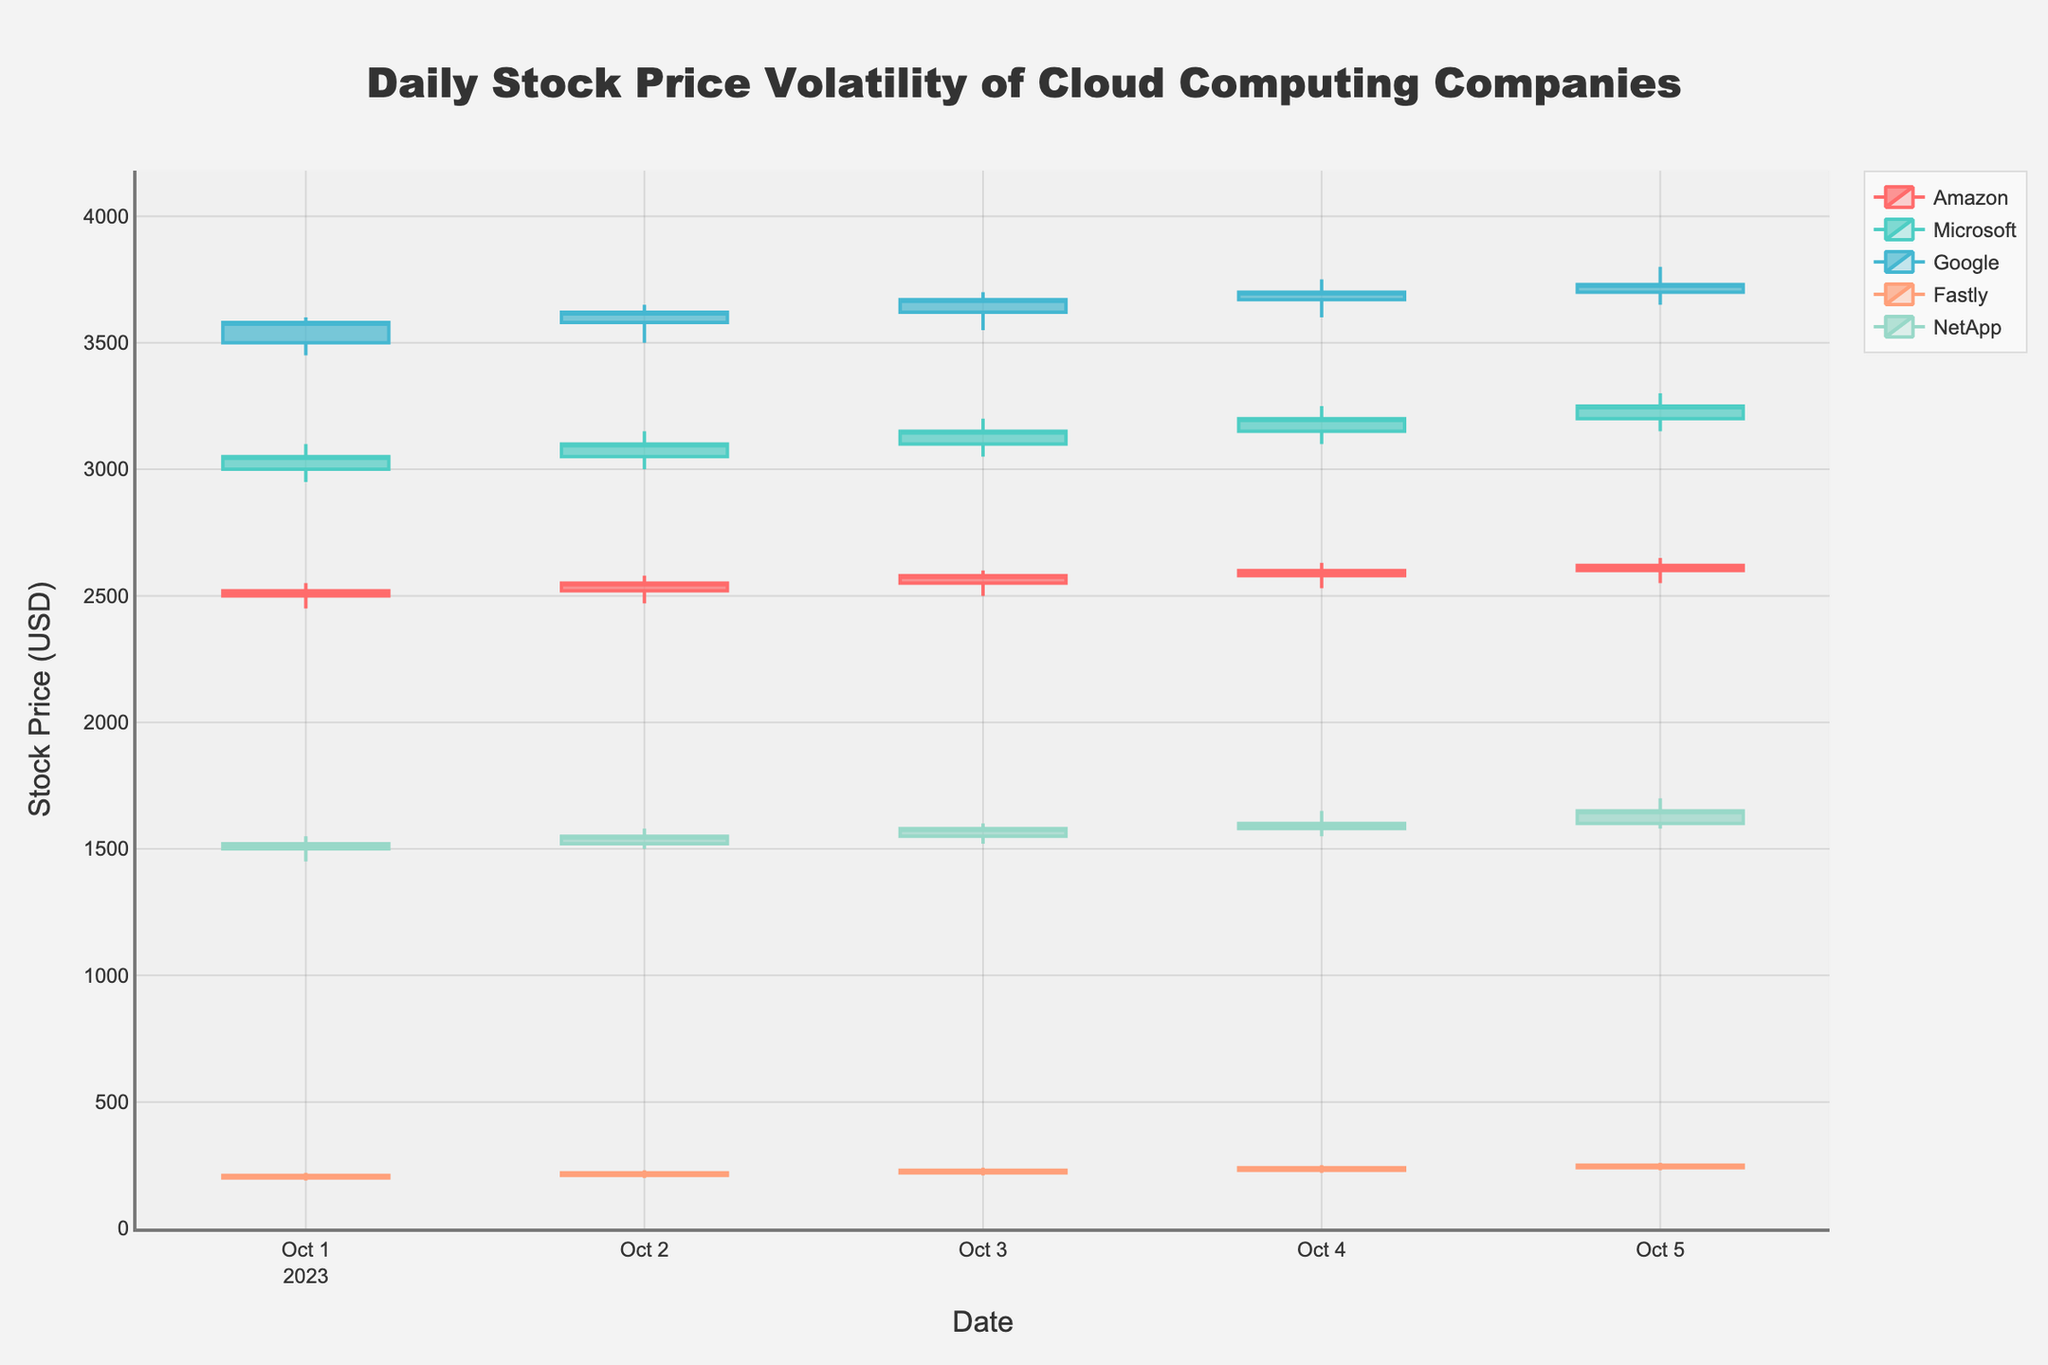Which company had the highest stock price on October 5th? Look for the highest 'High' value on October 5th in the candlestick plot and observe the corresponding company name. Google had the highest value at $3800 on October 5th.
Answer: Google What was the closing price of Microsoft on October 3rd? Look for the candlestick representing Microsoft for October 3rd and read the closing price. The closing price of Microsoft on October 3rd was $3150.
Answer: $3150 Between Amazon and NetApp, which company had a larger range between its highest and lowest stock prices on October 2nd? Calculate the range as `High - Low` for both Amazon and NetApp on October 2nd. Amazon's range: $2580 - $2470 = $110. NetApp's range: $1580 - $1500 = $80. Amazon has the larger range.
Answer: Amazon Which day did Fastly have the highest trading volume? Identify the volume values for Fastly over the days and compare them to find the maximum. Fastly's highest trading volume was 770000 on October 5th.
Answer: October 5th What is the overall trend of Google's stock prices from October 1st to October 5th? Observe the closing prices of Google's candlesticks over multiple days to determine if the stock is generally increasing, decreasing, or fluctuating. Google's closing prices show an increasing trend from October 1st to October 5th, moving from $3580 to $3730.
Answer: Increasing Between October 3rd and October 4th, did Amazon's stock price increase or decrease? Compare the closing prices of Amazon on October 3rd and October 4th in the candlestick plot. Amazon's closing price increased from $2580 on October 3rd to $2600 on October 4th.
Answer: Increased How does the volume of shares traded by Fastly on October 4th compare to that of NetApp on the same day? Refer to the volume values of both companies on October 4th and compare them. Fastly traded 750000 shares, compared to NetApp's 500000 shares on October 4th. Fastly had a higher trading volume.
Answer: Fastly Over the five days, which company shows the most consistent closing prices? Analyze the closing prices for each company over the five-day period and determine which one has the least fluctuation. Compare closing prices for Amazon, Microsoft, Google, Fastly, and NetApp over the given days. Microsoft has relatively stable closing prices ranging between $3050 and $3250.
Answer: Microsoft By how much did NetApp's closing price change from October 1st to October 5th? Subtract the closing price of NetApp on October 1st from the closing price on October 5th. Closing price on October 5th ($1650) - Closing price on October 1st ($1520) = $130.
Answer: $130 Which company had the smallest difference in its opening and closing prices on October 1st? Calculate the differences between opening and closing prices for each company on October 1st, and identify the smallest value. Amazon: $2520-$2500=$20, Microsoft: $3050-$3000=$50, Google: $3580-$3500=$80, Fastly: $210-$200=$10, NetApp: $1520-$1500=$20. Fastly had the smallest difference of $10.
Answer: Fastly 